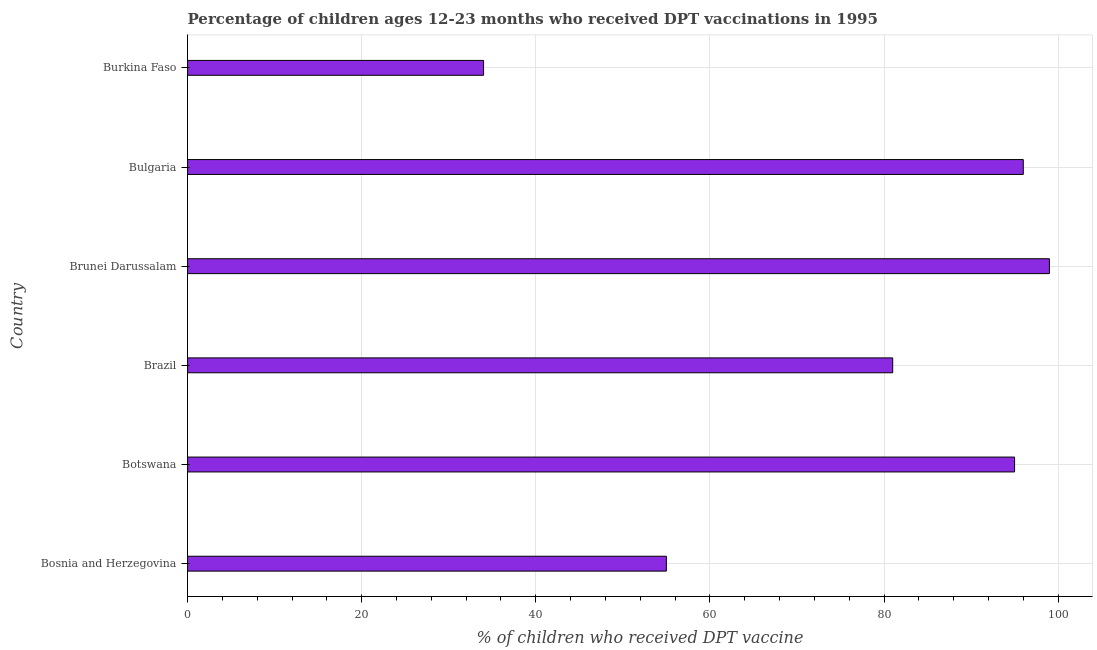Does the graph contain any zero values?
Ensure brevity in your answer.  No. Does the graph contain grids?
Provide a short and direct response. Yes. What is the title of the graph?
Offer a terse response. Percentage of children ages 12-23 months who received DPT vaccinations in 1995. What is the label or title of the X-axis?
Offer a very short reply. % of children who received DPT vaccine. What is the percentage of children who received dpt vaccine in Bosnia and Herzegovina?
Provide a short and direct response. 55. Across all countries, what is the maximum percentage of children who received dpt vaccine?
Keep it short and to the point. 99. In which country was the percentage of children who received dpt vaccine maximum?
Provide a short and direct response. Brunei Darussalam. In which country was the percentage of children who received dpt vaccine minimum?
Make the answer very short. Burkina Faso. What is the sum of the percentage of children who received dpt vaccine?
Ensure brevity in your answer.  460. What is the average percentage of children who received dpt vaccine per country?
Ensure brevity in your answer.  76.67. What is the ratio of the percentage of children who received dpt vaccine in Brazil to that in Burkina Faso?
Your response must be concise. 2.38. Is the percentage of children who received dpt vaccine in Bosnia and Herzegovina less than that in Botswana?
Your response must be concise. Yes. Is the difference between the percentage of children who received dpt vaccine in Bosnia and Herzegovina and Brazil greater than the difference between any two countries?
Offer a very short reply. No. Are all the bars in the graph horizontal?
Offer a terse response. Yes. What is the difference between two consecutive major ticks on the X-axis?
Offer a terse response. 20. Are the values on the major ticks of X-axis written in scientific E-notation?
Keep it short and to the point. No. What is the % of children who received DPT vaccine of Botswana?
Give a very brief answer. 95. What is the % of children who received DPT vaccine of Brazil?
Your response must be concise. 81. What is the % of children who received DPT vaccine in Brunei Darussalam?
Offer a terse response. 99. What is the % of children who received DPT vaccine in Bulgaria?
Provide a succinct answer. 96. What is the % of children who received DPT vaccine of Burkina Faso?
Ensure brevity in your answer.  34. What is the difference between the % of children who received DPT vaccine in Bosnia and Herzegovina and Botswana?
Give a very brief answer. -40. What is the difference between the % of children who received DPT vaccine in Bosnia and Herzegovina and Brunei Darussalam?
Offer a very short reply. -44. What is the difference between the % of children who received DPT vaccine in Bosnia and Herzegovina and Bulgaria?
Offer a very short reply. -41. What is the difference between the % of children who received DPT vaccine in Botswana and Burkina Faso?
Your answer should be compact. 61. What is the difference between the % of children who received DPT vaccine in Brazil and Bulgaria?
Make the answer very short. -15. What is the difference between the % of children who received DPT vaccine in Brazil and Burkina Faso?
Your answer should be very brief. 47. What is the difference between the % of children who received DPT vaccine in Brunei Darussalam and Burkina Faso?
Offer a terse response. 65. What is the ratio of the % of children who received DPT vaccine in Bosnia and Herzegovina to that in Botswana?
Your answer should be very brief. 0.58. What is the ratio of the % of children who received DPT vaccine in Bosnia and Herzegovina to that in Brazil?
Your answer should be very brief. 0.68. What is the ratio of the % of children who received DPT vaccine in Bosnia and Herzegovina to that in Brunei Darussalam?
Ensure brevity in your answer.  0.56. What is the ratio of the % of children who received DPT vaccine in Bosnia and Herzegovina to that in Bulgaria?
Provide a succinct answer. 0.57. What is the ratio of the % of children who received DPT vaccine in Bosnia and Herzegovina to that in Burkina Faso?
Offer a very short reply. 1.62. What is the ratio of the % of children who received DPT vaccine in Botswana to that in Brazil?
Offer a very short reply. 1.17. What is the ratio of the % of children who received DPT vaccine in Botswana to that in Burkina Faso?
Make the answer very short. 2.79. What is the ratio of the % of children who received DPT vaccine in Brazil to that in Brunei Darussalam?
Make the answer very short. 0.82. What is the ratio of the % of children who received DPT vaccine in Brazil to that in Bulgaria?
Your answer should be compact. 0.84. What is the ratio of the % of children who received DPT vaccine in Brazil to that in Burkina Faso?
Provide a short and direct response. 2.38. What is the ratio of the % of children who received DPT vaccine in Brunei Darussalam to that in Bulgaria?
Your response must be concise. 1.03. What is the ratio of the % of children who received DPT vaccine in Brunei Darussalam to that in Burkina Faso?
Your response must be concise. 2.91. What is the ratio of the % of children who received DPT vaccine in Bulgaria to that in Burkina Faso?
Offer a very short reply. 2.82. 